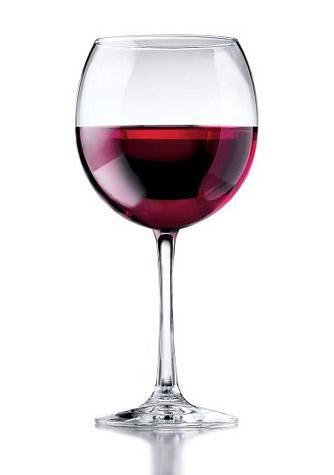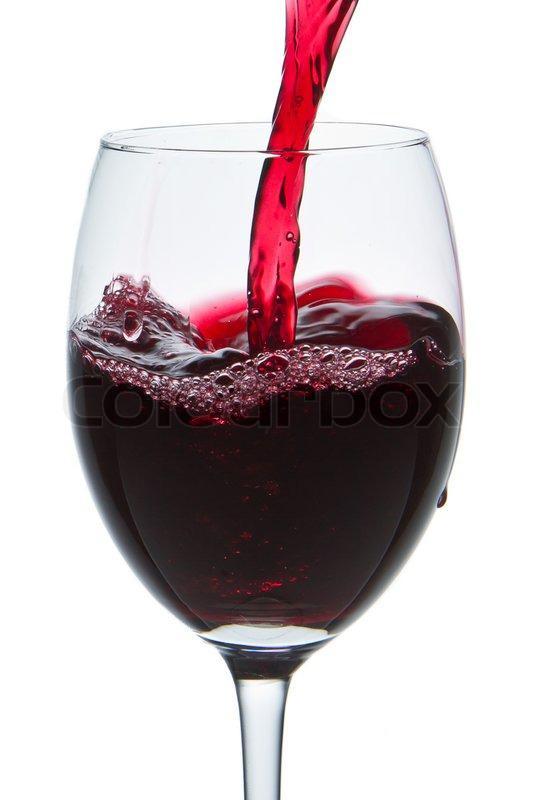The first image is the image on the left, the second image is the image on the right. Analyze the images presented: Is the assertion "There are two glasses in each of the images." valid? Answer yes or no. No. The first image is the image on the left, the second image is the image on the right. Evaluate the accuracy of this statement regarding the images: "The left image contains two glasses of wine.". Is it true? Answer yes or no. No. 